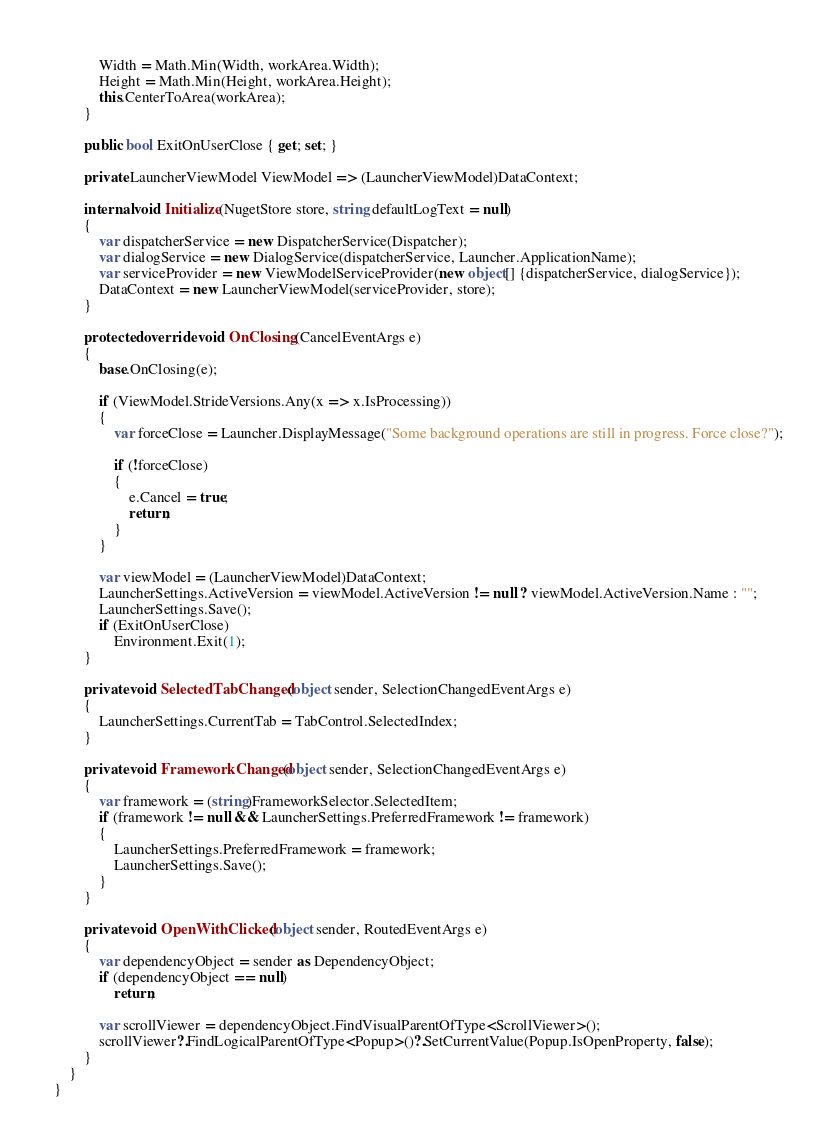Convert code to text. <code><loc_0><loc_0><loc_500><loc_500><_C#_>            Width = Math.Min(Width, workArea.Width);
            Height = Math.Min(Height, workArea.Height);
            this.CenterToArea(workArea);
        }

        public bool ExitOnUserClose { get; set; }
        
        private LauncherViewModel ViewModel => (LauncherViewModel)DataContext;

        internal void Initialize(NugetStore store, string defaultLogText = null)
        {
            var dispatcherService = new DispatcherService(Dispatcher);
            var dialogService = new DialogService(dispatcherService, Launcher.ApplicationName);
            var serviceProvider = new ViewModelServiceProvider(new object[] {dispatcherService, dialogService});
            DataContext = new LauncherViewModel(serviceProvider, store);
        }

        protected override void OnClosing(CancelEventArgs e)
        {
            base.OnClosing(e);

            if (ViewModel.StrideVersions.Any(x => x.IsProcessing))
            {
                var forceClose = Launcher.DisplayMessage("Some background operations are still in progress. Force close?");

                if (!forceClose)
                {
                    e.Cancel = true;
                    return;
                }
            }

            var viewModel = (LauncherViewModel)DataContext;
            LauncherSettings.ActiveVersion = viewModel.ActiveVersion != null ? viewModel.ActiveVersion.Name : ""; 
            LauncherSettings.Save();
            if (ExitOnUserClose)
                Environment.Exit(1);
        }

        private void SelectedTabChanged(object sender, SelectionChangedEventArgs e)
        {
            LauncherSettings.CurrentTab = TabControl.SelectedIndex;
        }

        private void FrameworkChanged(object sender, SelectionChangedEventArgs e)
        {
            var framework = (string)FrameworkSelector.SelectedItem;
            if (framework != null && LauncherSettings.PreferredFramework != framework)
            {
                LauncherSettings.PreferredFramework = framework;
                LauncherSettings.Save();
            }
        }

        private void OpenWithClicked(object sender, RoutedEventArgs e)
        {
            var dependencyObject = sender as DependencyObject;
            if (dependencyObject == null)
                return;

            var scrollViewer = dependencyObject.FindVisualParentOfType<ScrollViewer>();
            scrollViewer?.FindLogicalParentOfType<Popup>()?.SetCurrentValue(Popup.IsOpenProperty, false);
        }
    }
}
</code> 